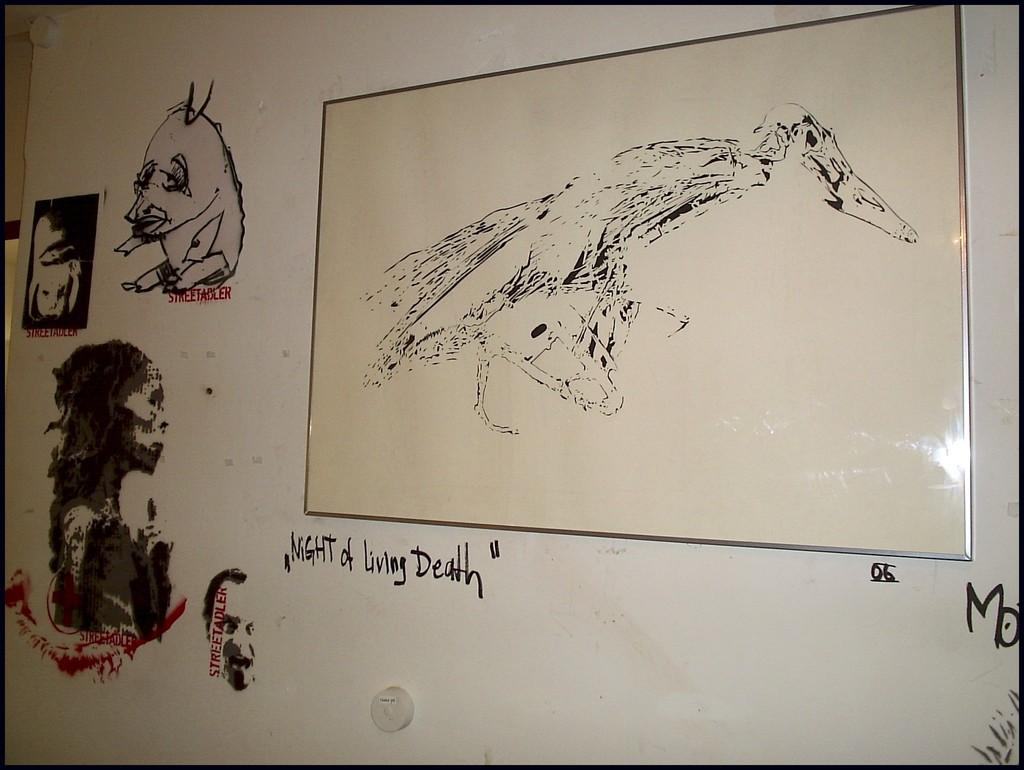What type of artwork can be seen on the wall in the image? There are paintings on the wall in the image. Are there any words or phrases on the wall? Yes, there is text on the wall in the image. What other decorative item is present on the wall? There is a photo frame on the wall in the image. What type of jar is visible on the wall in the image? There is no jar present on the wall in the image. What type of appliance can be seen in the photo frame on the wall? There is no appliance visible in the photo frame on the wall in the image. 